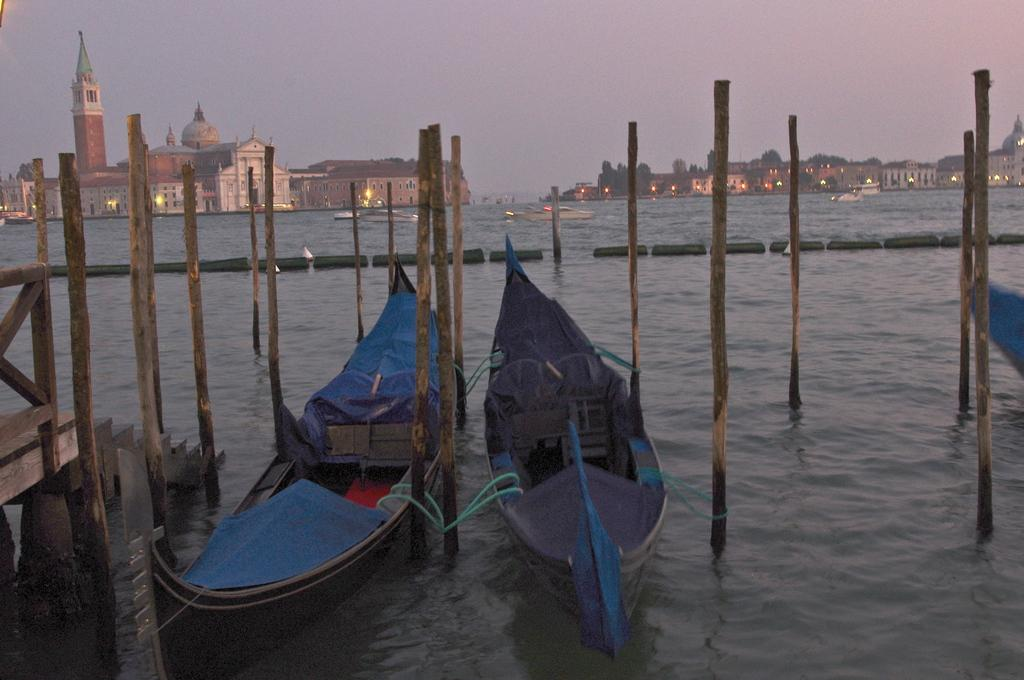What type of vehicles can be seen in the image? There are boats in the image. What objects are used to support the boats? Bamboo poles are present in the image to support the boats. What is visible at the bottom of the image? There is water visible at the bottom of the image. What can be seen in the distance in the image? There are buildings and the sky visible in the background of the image. How many jellyfish can be seen swimming in the water in the image? There are no jellyfish present in the image; it features boats and bamboo poles in the water. What type of attraction is present in the image? There is no specific attraction mentioned or depicted in the image; it primarily shows boats and their support structures. 